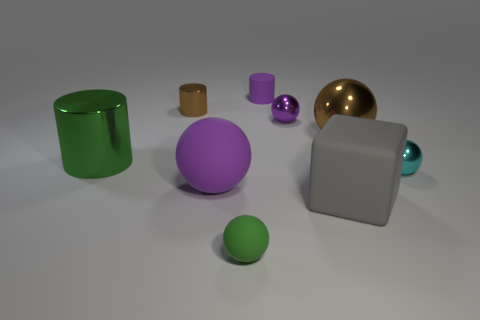What size is the green shiny object that is the same shape as the tiny brown object?
Provide a short and direct response. Large. Is there a tiny purple cylinder that is behind the small rubber object that is in front of the green shiny object?
Give a very brief answer. Yes. Is the color of the small rubber ball the same as the big metal cylinder?
Provide a succinct answer. Yes. What number of other objects are there of the same shape as the cyan thing?
Give a very brief answer. 4. Is the number of tiny cylinders to the right of the brown shiny ball greater than the number of tiny spheres left of the purple matte sphere?
Your answer should be very brief. No. There is a shiny cylinder that is to the right of the big green object; does it have the same size as the brown metallic object that is in front of the purple metal ball?
Your response must be concise. No. What is the shape of the tiny cyan object?
Your answer should be very brief. Sphere. There is a thing that is the same color as the large metal ball; what is its size?
Keep it short and to the point. Small. What is the color of the large cylinder that is made of the same material as the large brown object?
Your response must be concise. Green. Do the large brown ball and the small purple object that is in front of the small brown cylinder have the same material?
Provide a succinct answer. Yes. 